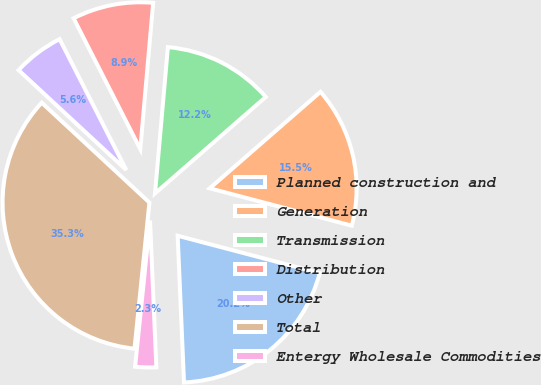Convert chart. <chart><loc_0><loc_0><loc_500><loc_500><pie_chart><fcel>Planned construction and<fcel>Generation<fcel>Transmission<fcel>Distribution<fcel>Other<fcel>Total<fcel>Entergy Wholesale Commodities<nl><fcel>20.22%<fcel>15.5%<fcel>12.2%<fcel>8.9%<fcel>5.6%<fcel>35.28%<fcel>2.31%<nl></chart> 